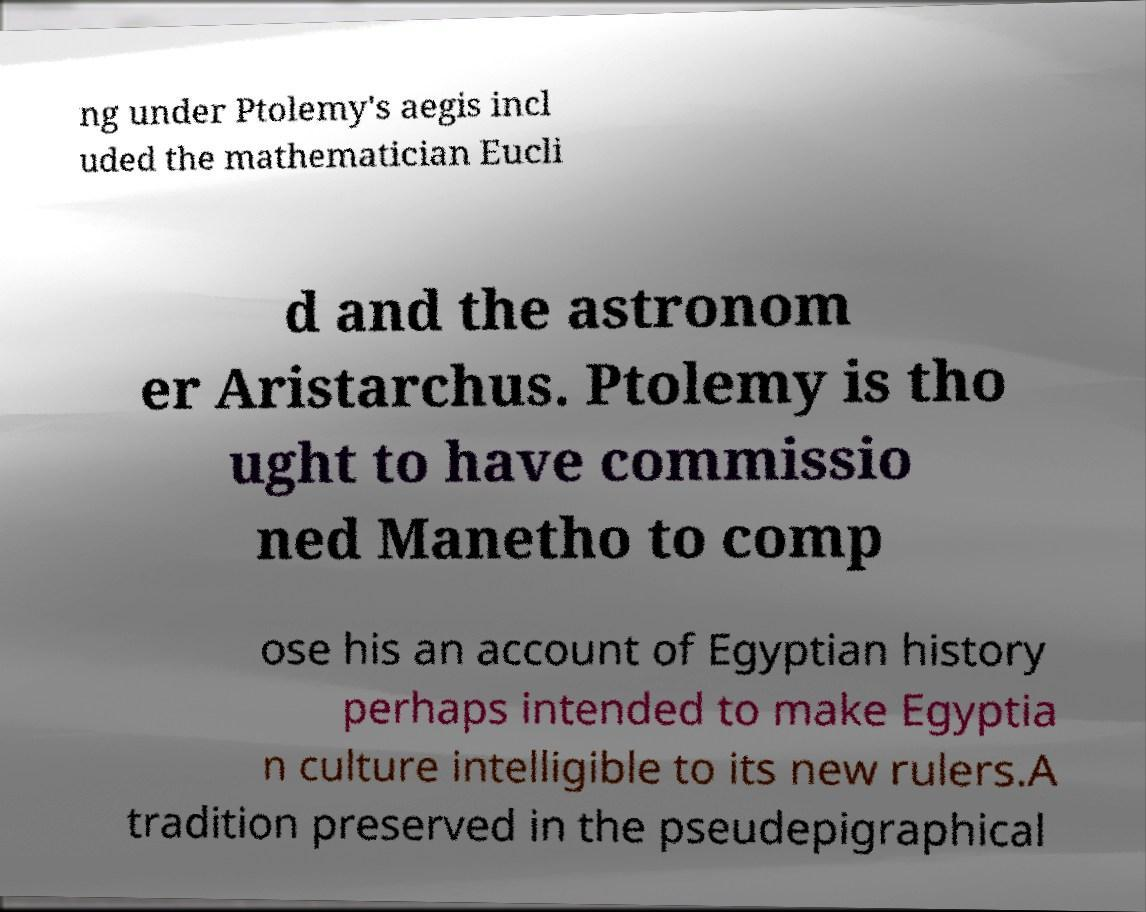What messages or text are displayed in this image? I need them in a readable, typed format. ng under Ptolemy's aegis incl uded the mathematician Eucli d and the astronom er Aristarchus. Ptolemy is tho ught to have commissio ned Manetho to comp ose his an account of Egyptian history perhaps intended to make Egyptia n culture intelligible to its new rulers.A tradition preserved in the pseudepigraphical 